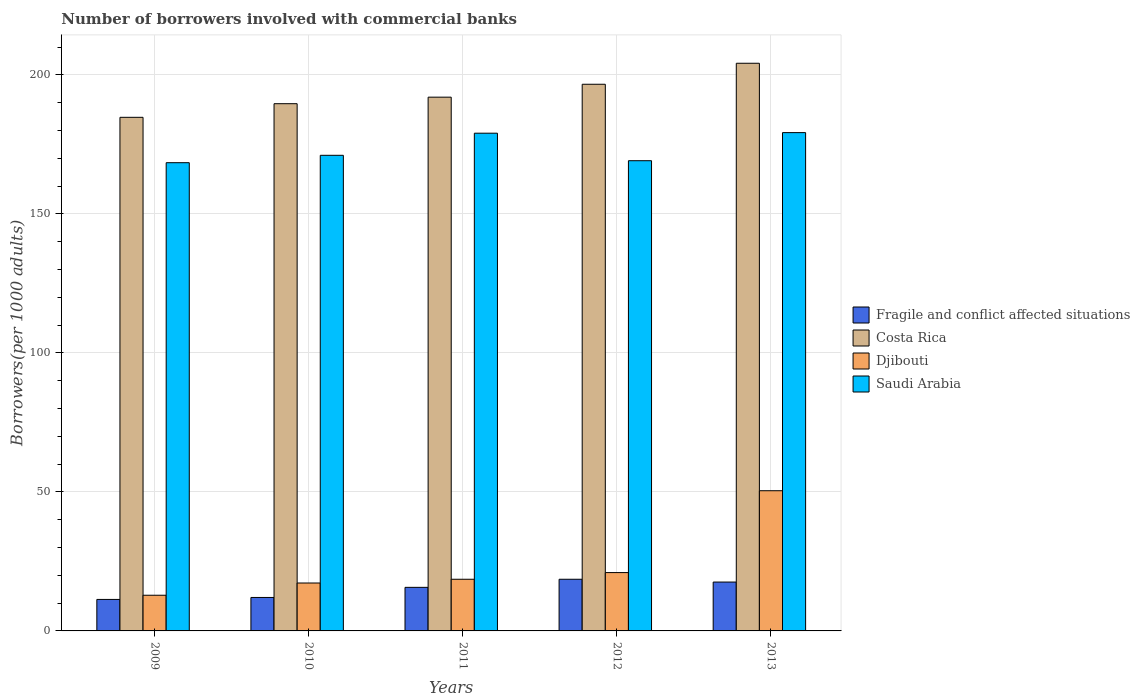How many different coloured bars are there?
Your answer should be very brief. 4. Are the number of bars on each tick of the X-axis equal?
Keep it short and to the point. Yes. How many bars are there on the 4th tick from the left?
Make the answer very short. 4. What is the number of borrowers involved with commercial banks in Djibouti in 2009?
Offer a very short reply. 12.83. Across all years, what is the maximum number of borrowers involved with commercial banks in Fragile and conflict affected situations?
Your response must be concise. 18.58. Across all years, what is the minimum number of borrowers involved with commercial banks in Costa Rica?
Keep it short and to the point. 184.73. In which year was the number of borrowers involved with commercial banks in Saudi Arabia maximum?
Provide a short and direct response. 2013. What is the total number of borrowers involved with commercial banks in Fragile and conflict affected situations in the graph?
Make the answer very short. 75.19. What is the difference between the number of borrowers involved with commercial banks in Fragile and conflict affected situations in 2010 and that in 2012?
Ensure brevity in your answer.  -6.55. What is the difference between the number of borrowers involved with commercial banks in Saudi Arabia in 2011 and the number of borrowers involved with commercial banks in Djibouti in 2012?
Your answer should be very brief. 158.04. What is the average number of borrowers involved with commercial banks in Djibouti per year?
Offer a terse response. 24.01. In the year 2009, what is the difference between the number of borrowers involved with commercial banks in Fragile and conflict affected situations and number of borrowers involved with commercial banks in Djibouti?
Provide a short and direct response. -1.5. In how many years, is the number of borrowers involved with commercial banks in Djibouti greater than 120?
Ensure brevity in your answer.  0. What is the ratio of the number of borrowers involved with commercial banks in Djibouti in 2009 to that in 2013?
Provide a short and direct response. 0.25. Is the difference between the number of borrowers involved with commercial banks in Fragile and conflict affected situations in 2012 and 2013 greater than the difference between the number of borrowers involved with commercial banks in Djibouti in 2012 and 2013?
Offer a terse response. Yes. What is the difference between the highest and the second highest number of borrowers involved with commercial banks in Fragile and conflict affected situations?
Make the answer very short. 1. What is the difference between the highest and the lowest number of borrowers involved with commercial banks in Costa Rica?
Offer a very short reply. 19.45. In how many years, is the number of borrowers involved with commercial banks in Costa Rica greater than the average number of borrowers involved with commercial banks in Costa Rica taken over all years?
Give a very brief answer. 2. What does the 4th bar from the left in 2011 represents?
Make the answer very short. Saudi Arabia. What does the 4th bar from the right in 2012 represents?
Make the answer very short. Fragile and conflict affected situations. Is it the case that in every year, the sum of the number of borrowers involved with commercial banks in Fragile and conflict affected situations and number of borrowers involved with commercial banks in Costa Rica is greater than the number of borrowers involved with commercial banks in Djibouti?
Your response must be concise. Yes. How many bars are there?
Ensure brevity in your answer.  20. Are all the bars in the graph horizontal?
Ensure brevity in your answer.  No. How many years are there in the graph?
Ensure brevity in your answer.  5. What is the difference between two consecutive major ticks on the Y-axis?
Give a very brief answer. 50. Does the graph contain any zero values?
Offer a very short reply. No. Does the graph contain grids?
Your response must be concise. Yes. Where does the legend appear in the graph?
Your response must be concise. Center right. How are the legend labels stacked?
Provide a succinct answer. Vertical. What is the title of the graph?
Your response must be concise. Number of borrowers involved with commercial banks. What is the label or title of the Y-axis?
Keep it short and to the point. Borrowers(per 1000 adults). What is the Borrowers(per 1000 adults) in Fragile and conflict affected situations in 2009?
Make the answer very short. 11.33. What is the Borrowers(per 1000 adults) in Costa Rica in 2009?
Your answer should be compact. 184.73. What is the Borrowers(per 1000 adults) in Djibouti in 2009?
Give a very brief answer. 12.83. What is the Borrowers(per 1000 adults) of Saudi Arabia in 2009?
Keep it short and to the point. 168.41. What is the Borrowers(per 1000 adults) in Fragile and conflict affected situations in 2010?
Keep it short and to the point. 12.03. What is the Borrowers(per 1000 adults) of Costa Rica in 2010?
Your answer should be compact. 189.63. What is the Borrowers(per 1000 adults) in Djibouti in 2010?
Make the answer very short. 17.23. What is the Borrowers(per 1000 adults) in Saudi Arabia in 2010?
Give a very brief answer. 171.07. What is the Borrowers(per 1000 adults) in Fragile and conflict affected situations in 2011?
Provide a succinct answer. 15.67. What is the Borrowers(per 1000 adults) in Costa Rica in 2011?
Your answer should be compact. 191.98. What is the Borrowers(per 1000 adults) of Djibouti in 2011?
Make the answer very short. 18.58. What is the Borrowers(per 1000 adults) in Saudi Arabia in 2011?
Offer a very short reply. 179.02. What is the Borrowers(per 1000 adults) of Fragile and conflict affected situations in 2012?
Keep it short and to the point. 18.58. What is the Borrowers(per 1000 adults) in Costa Rica in 2012?
Your answer should be compact. 196.62. What is the Borrowers(per 1000 adults) in Djibouti in 2012?
Your answer should be compact. 20.98. What is the Borrowers(per 1000 adults) in Saudi Arabia in 2012?
Your answer should be compact. 169.13. What is the Borrowers(per 1000 adults) in Fragile and conflict affected situations in 2013?
Your answer should be compact. 17.58. What is the Borrowers(per 1000 adults) in Costa Rica in 2013?
Ensure brevity in your answer.  204.18. What is the Borrowers(per 1000 adults) of Djibouti in 2013?
Make the answer very short. 50.43. What is the Borrowers(per 1000 adults) in Saudi Arabia in 2013?
Give a very brief answer. 179.23. Across all years, what is the maximum Borrowers(per 1000 adults) in Fragile and conflict affected situations?
Provide a succinct answer. 18.58. Across all years, what is the maximum Borrowers(per 1000 adults) in Costa Rica?
Your answer should be very brief. 204.18. Across all years, what is the maximum Borrowers(per 1000 adults) of Djibouti?
Make the answer very short. 50.43. Across all years, what is the maximum Borrowers(per 1000 adults) of Saudi Arabia?
Your answer should be very brief. 179.23. Across all years, what is the minimum Borrowers(per 1000 adults) in Fragile and conflict affected situations?
Provide a succinct answer. 11.33. Across all years, what is the minimum Borrowers(per 1000 adults) of Costa Rica?
Give a very brief answer. 184.73. Across all years, what is the minimum Borrowers(per 1000 adults) of Djibouti?
Offer a terse response. 12.83. Across all years, what is the minimum Borrowers(per 1000 adults) in Saudi Arabia?
Offer a very short reply. 168.41. What is the total Borrowers(per 1000 adults) of Fragile and conflict affected situations in the graph?
Offer a very short reply. 75.19. What is the total Borrowers(per 1000 adults) of Costa Rica in the graph?
Offer a terse response. 967.14. What is the total Borrowers(per 1000 adults) of Djibouti in the graph?
Provide a succinct answer. 120.05. What is the total Borrowers(per 1000 adults) in Saudi Arabia in the graph?
Keep it short and to the point. 866.85. What is the difference between the Borrowers(per 1000 adults) in Fragile and conflict affected situations in 2009 and that in 2010?
Ensure brevity in your answer.  -0.7. What is the difference between the Borrowers(per 1000 adults) in Costa Rica in 2009 and that in 2010?
Give a very brief answer. -4.9. What is the difference between the Borrowers(per 1000 adults) in Djibouti in 2009 and that in 2010?
Provide a succinct answer. -4.4. What is the difference between the Borrowers(per 1000 adults) in Saudi Arabia in 2009 and that in 2010?
Your response must be concise. -2.65. What is the difference between the Borrowers(per 1000 adults) in Fragile and conflict affected situations in 2009 and that in 2011?
Offer a very short reply. -4.34. What is the difference between the Borrowers(per 1000 adults) in Costa Rica in 2009 and that in 2011?
Provide a short and direct response. -7.25. What is the difference between the Borrowers(per 1000 adults) of Djibouti in 2009 and that in 2011?
Your answer should be very brief. -5.75. What is the difference between the Borrowers(per 1000 adults) in Saudi Arabia in 2009 and that in 2011?
Make the answer very short. -10.61. What is the difference between the Borrowers(per 1000 adults) in Fragile and conflict affected situations in 2009 and that in 2012?
Ensure brevity in your answer.  -7.25. What is the difference between the Borrowers(per 1000 adults) in Costa Rica in 2009 and that in 2012?
Your answer should be very brief. -11.9. What is the difference between the Borrowers(per 1000 adults) in Djibouti in 2009 and that in 2012?
Provide a short and direct response. -8.15. What is the difference between the Borrowers(per 1000 adults) in Saudi Arabia in 2009 and that in 2012?
Ensure brevity in your answer.  -0.71. What is the difference between the Borrowers(per 1000 adults) of Fragile and conflict affected situations in 2009 and that in 2013?
Offer a terse response. -6.25. What is the difference between the Borrowers(per 1000 adults) of Costa Rica in 2009 and that in 2013?
Give a very brief answer. -19.45. What is the difference between the Borrowers(per 1000 adults) in Djibouti in 2009 and that in 2013?
Keep it short and to the point. -37.59. What is the difference between the Borrowers(per 1000 adults) in Saudi Arabia in 2009 and that in 2013?
Offer a very short reply. -10.82. What is the difference between the Borrowers(per 1000 adults) of Fragile and conflict affected situations in 2010 and that in 2011?
Give a very brief answer. -3.64. What is the difference between the Borrowers(per 1000 adults) of Costa Rica in 2010 and that in 2011?
Ensure brevity in your answer.  -2.35. What is the difference between the Borrowers(per 1000 adults) of Djibouti in 2010 and that in 2011?
Keep it short and to the point. -1.35. What is the difference between the Borrowers(per 1000 adults) in Saudi Arabia in 2010 and that in 2011?
Your answer should be very brief. -7.96. What is the difference between the Borrowers(per 1000 adults) of Fragile and conflict affected situations in 2010 and that in 2012?
Ensure brevity in your answer.  -6.55. What is the difference between the Borrowers(per 1000 adults) of Costa Rica in 2010 and that in 2012?
Provide a succinct answer. -6.99. What is the difference between the Borrowers(per 1000 adults) of Djibouti in 2010 and that in 2012?
Ensure brevity in your answer.  -3.75. What is the difference between the Borrowers(per 1000 adults) in Saudi Arabia in 2010 and that in 2012?
Make the answer very short. 1.94. What is the difference between the Borrowers(per 1000 adults) in Fragile and conflict affected situations in 2010 and that in 2013?
Provide a short and direct response. -5.55. What is the difference between the Borrowers(per 1000 adults) in Costa Rica in 2010 and that in 2013?
Ensure brevity in your answer.  -14.55. What is the difference between the Borrowers(per 1000 adults) in Djibouti in 2010 and that in 2013?
Your answer should be very brief. -33.19. What is the difference between the Borrowers(per 1000 adults) in Saudi Arabia in 2010 and that in 2013?
Provide a succinct answer. -8.16. What is the difference between the Borrowers(per 1000 adults) of Fragile and conflict affected situations in 2011 and that in 2012?
Your response must be concise. -2.91. What is the difference between the Borrowers(per 1000 adults) in Costa Rica in 2011 and that in 2012?
Keep it short and to the point. -4.64. What is the difference between the Borrowers(per 1000 adults) of Djibouti in 2011 and that in 2012?
Make the answer very short. -2.4. What is the difference between the Borrowers(per 1000 adults) in Saudi Arabia in 2011 and that in 2012?
Ensure brevity in your answer.  9.9. What is the difference between the Borrowers(per 1000 adults) of Fragile and conflict affected situations in 2011 and that in 2013?
Keep it short and to the point. -1.91. What is the difference between the Borrowers(per 1000 adults) in Costa Rica in 2011 and that in 2013?
Your answer should be very brief. -12.19. What is the difference between the Borrowers(per 1000 adults) in Djibouti in 2011 and that in 2013?
Give a very brief answer. -31.85. What is the difference between the Borrowers(per 1000 adults) of Saudi Arabia in 2011 and that in 2013?
Offer a very short reply. -0.21. What is the difference between the Borrowers(per 1000 adults) of Costa Rica in 2012 and that in 2013?
Keep it short and to the point. -7.55. What is the difference between the Borrowers(per 1000 adults) of Djibouti in 2012 and that in 2013?
Your response must be concise. -29.45. What is the difference between the Borrowers(per 1000 adults) of Saudi Arabia in 2012 and that in 2013?
Your answer should be very brief. -10.1. What is the difference between the Borrowers(per 1000 adults) of Fragile and conflict affected situations in 2009 and the Borrowers(per 1000 adults) of Costa Rica in 2010?
Give a very brief answer. -178.3. What is the difference between the Borrowers(per 1000 adults) in Fragile and conflict affected situations in 2009 and the Borrowers(per 1000 adults) in Djibouti in 2010?
Your answer should be compact. -5.91. What is the difference between the Borrowers(per 1000 adults) in Fragile and conflict affected situations in 2009 and the Borrowers(per 1000 adults) in Saudi Arabia in 2010?
Provide a succinct answer. -159.74. What is the difference between the Borrowers(per 1000 adults) in Costa Rica in 2009 and the Borrowers(per 1000 adults) in Djibouti in 2010?
Provide a succinct answer. 167.49. What is the difference between the Borrowers(per 1000 adults) in Costa Rica in 2009 and the Borrowers(per 1000 adults) in Saudi Arabia in 2010?
Your response must be concise. 13.66. What is the difference between the Borrowers(per 1000 adults) in Djibouti in 2009 and the Borrowers(per 1000 adults) in Saudi Arabia in 2010?
Your answer should be compact. -158.23. What is the difference between the Borrowers(per 1000 adults) of Fragile and conflict affected situations in 2009 and the Borrowers(per 1000 adults) of Costa Rica in 2011?
Offer a terse response. -180.65. What is the difference between the Borrowers(per 1000 adults) of Fragile and conflict affected situations in 2009 and the Borrowers(per 1000 adults) of Djibouti in 2011?
Offer a very short reply. -7.25. What is the difference between the Borrowers(per 1000 adults) of Fragile and conflict affected situations in 2009 and the Borrowers(per 1000 adults) of Saudi Arabia in 2011?
Ensure brevity in your answer.  -167.69. What is the difference between the Borrowers(per 1000 adults) of Costa Rica in 2009 and the Borrowers(per 1000 adults) of Djibouti in 2011?
Offer a terse response. 166.15. What is the difference between the Borrowers(per 1000 adults) of Costa Rica in 2009 and the Borrowers(per 1000 adults) of Saudi Arabia in 2011?
Your answer should be very brief. 5.71. What is the difference between the Borrowers(per 1000 adults) of Djibouti in 2009 and the Borrowers(per 1000 adults) of Saudi Arabia in 2011?
Provide a short and direct response. -166.19. What is the difference between the Borrowers(per 1000 adults) in Fragile and conflict affected situations in 2009 and the Borrowers(per 1000 adults) in Costa Rica in 2012?
Your answer should be very brief. -185.29. What is the difference between the Borrowers(per 1000 adults) in Fragile and conflict affected situations in 2009 and the Borrowers(per 1000 adults) in Djibouti in 2012?
Keep it short and to the point. -9.65. What is the difference between the Borrowers(per 1000 adults) of Fragile and conflict affected situations in 2009 and the Borrowers(per 1000 adults) of Saudi Arabia in 2012?
Give a very brief answer. -157.8. What is the difference between the Borrowers(per 1000 adults) in Costa Rica in 2009 and the Borrowers(per 1000 adults) in Djibouti in 2012?
Ensure brevity in your answer.  163.75. What is the difference between the Borrowers(per 1000 adults) of Costa Rica in 2009 and the Borrowers(per 1000 adults) of Saudi Arabia in 2012?
Provide a succinct answer. 15.6. What is the difference between the Borrowers(per 1000 adults) in Djibouti in 2009 and the Borrowers(per 1000 adults) in Saudi Arabia in 2012?
Your answer should be compact. -156.29. What is the difference between the Borrowers(per 1000 adults) of Fragile and conflict affected situations in 2009 and the Borrowers(per 1000 adults) of Costa Rica in 2013?
Keep it short and to the point. -192.85. What is the difference between the Borrowers(per 1000 adults) of Fragile and conflict affected situations in 2009 and the Borrowers(per 1000 adults) of Djibouti in 2013?
Make the answer very short. -39.1. What is the difference between the Borrowers(per 1000 adults) in Fragile and conflict affected situations in 2009 and the Borrowers(per 1000 adults) in Saudi Arabia in 2013?
Offer a terse response. -167.9. What is the difference between the Borrowers(per 1000 adults) in Costa Rica in 2009 and the Borrowers(per 1000 adults) in Djibouti in 2013?
Ensure brevity in your answer.  134.3. What is the difference between the Borrowers(per 1000 adults) of Costa Rica in 2009 and the Borrowers(per 1000 adults) of Saudi Arabia in 2013?
Make the answer very short. 5.5. What is the difference between the Borrowers(per 1000 adults) of Djibouti in 2009 and the Borrowers(per 1000 adults) of Saudi Arabia in 2013?
Provide a succinct answer. -166.4. What is the difference between the Borrowers(per 1000 adults) of Fragile and conflict affected situations in 2010 and the Borrowers(per 1000 adults) of Costa Rica in 2011?
Keep it short and to the point. -179.95. What is the difference between the Borrowers(per 1000 adults) of Fragile and conflict affected situations in 2010 and the Borrowers(per 1000 adults) of Djibouti in 2011?
Your answer should be very brief. -6.55. What is the difference between the Borrowers(per 1000 adults) of Fragile and conflict affected situations in 2010 and the Borrowers(per 1000 adults) of Saudi Arabia in 2011?
Your answer should be compact. -166.99. What is the difference between the Borrowers(per 1000 adults) in Costa Rica in 2010 and the Borrowers(per 1000 adults) in Djibouti in 2011?
Your response must be concise. 171.05. What is the difference between the Borrowers(per 1000 adults) of Costa Rica in 2010 and the Borrowers(per 1000 adults) of Saudi Arabia in 2011?
Offer a terse response. 10.61. What is the difference between the Borrowers(per 1000 adults) in Djibouti in 2010 and the Borrowers(per 1000 adults) in Saudi Arabia in 2011?
Ensure brevity in your answer.  -161.79. What is the difference between the Borrowers(per 1000 adults) in Fragile and conflict affected situations in 2010 and the Borrowers(per 1000 adults) in Costa Rica in 2012?
Provide a short and direct response. -184.59. What is the difference between the Borrowers(per 1000 adults) in Fragile and conflict affected situations in 2010 and the Borrowers(per 1000 adults) in Djibouti in 2012?
Ensure brevity in your answer.  -8.95. What is the difference between the Borrowers(per 1000 adults) of Fragile and conflict affected situations in 2010 and the Borrowers(per 1000 adults) of Saudi Arabia in 2012?
Offer a terse response. -157.09. What is the difference between the Borrowers(per 1000 adults) in Costa Rica in 2010 and the Borrowers(per 1000 adults) in Djibouti in 2012?
Provide a succinct answer. 168.65. What is the difference between the Borrowers(per 1000 adults) in Costa Rica in 2010 and the Borrowers(per 1000 adults) in Saudi Arabia in 2012?
Offer a very short reply. 20.5. What is the difference between the Borrowers(per 1000 adults) of Djibouti in 2010 and the Borrowers(per 1000 adults) of Saudi Arabia in 2012?
Keep it short and to the point. -151.89. What is the difference between the Borrowers(per 1000 adults) of Fragile and conflict affected situations in 2010 and the Borrowers(per 1000 adults) of Costa Rica in 2013?
Give a very brief answer. -192.14. What is the difference between the Borrowers(per 1000 adults) in Fragile and conflict affected situations in 2010 and the Borrowers(per 1000 adults) in Djibouti in 2013?
Provide a short and direct response. -38.39. What is the difference between the Borrowers(per 1000 adults) in Fragile and conflict affected situations in 2010 and the Borrowers(per 1000 adults) in Saudi Arabia in 2013?
Your answer should be compact. -167.2. What is the difference between the Borrowers(per 1000 adults) in Costa Rica in 2010 and the Borrowers(per 1000 adults) in Djibouti in 2013?
Provide a short and direct response. 139.2. What is the difference between the Borrowers(per 1000 adults) in Costa Rica in 2010 and the Borrowers(per 1000 adults) in Saudi Arabia in 2013?
Give a very brief answer. 10.4. What is the difference between the Borrowers(per 1000 adults) in Djibouti in 2010 and the Borrowers(per 1000 adults) in Saudi Arabia in 2013?
Give a very brief answer. -161.99. What is the difference between the Borrowers(per 1000 adults) of Fragile and conflict affected situations in 2011 and the Borrowers(per 1000 adults) of Costa Rica in 2012?
Ensure brevity in your answer.  -180.95. What is the difference between the Borrowers(per 1000 adults) of Fragile and conflict affected situations in 2011 and the Borrowers(per 1000 adults) of Djibouti in 2012?
Make the answer very short. -5.31. What is the difference between the Borrowers(per 1000 adults) of Fragile and conflict affected situations in 2011 and the Borrowers(per 1000 adults) of Saudi Arabia in 2012?
Keep it short and to the point. -153.46. What is the difference between the Borrowers(per 1000 adults) in Costa Rica in 2011 and the Borrowers(per 1000 adults) in Djibouti in 2012?
Your answer should be compact. 171. What is the difference between the Borrowers(per 1000 adults) in Costa Rica in 2011 and the Borrowers(per 1000 adults) in Saudi Arabia in 2012?
Provide a short and direct response. 22.86. What is the difference between the Borrowers(per 1000 adults) of Djibouti in 2011 and the Borrowers(per 1000 adults) of Saudi Arabia in 2012?
Your answer should be very brief. -150.55. What is the difference between the Borrowers(per 1000 adults) of Fragile and conflict affected situations in 2011 and the Borrowers(per 1000 adults) of Costa Rica in 2013?
Make the answer very short. -188.51. What is the difference between the Borrowers(per 1000 adults) of Fragile and conflict affected situations in 2011 and the Borrowers(per 1000 adults) of Djibouti in 2013?
Offer a terse response. -34.76. What is the difference between the Borrowers(per 1000 adults) in Fragile and conflict affected situations in 2011 and the Borrowers(per 1000 adults) in Saudi Arabia in 2013?
Provide a short and direct response. -163.56. What is the difference between the Borrowers(per 1000 adults) of Costa Rica in 2011 and the Borrowers(per 1000 adults) of Djibouti in 2013?
Provide a short and direct response. 141.56. What is the difference between the Borrowers(per 1000 adults) in Costa Rica in 2011 and the Borrowers(per 1000 adults) in Saudi Arabia in 2013?
Your answer should be very brief. 12.75. What is the difference between the Borrowers(per 1000 adults) of Djibouti in 2011 and the Borrowers(per 1000 adults) of Saudi Arabia in 2013?
Provide a short and direct response. -160.65. What is the difference between the Borrowers(per 1000 adults) in Fragile and conflict affected situations in 2012 and the Borrowers(per 1000 adults) in Costa Rica in 2013?
Your answer should be very brief. -185.59. What is the difference between the Borrowers(per 1000 adults) in Fragile and conflict affected situations in 2012 and the Borrowers(per 1000 adults) in Djibouti in 2013?
Provide a succinct answer. -31.84. What is the difference between the Borrowers(per 1000 adults) in Fragile and conflict affected situations in 2012 and the Borrowers(per 1000 adults) in Saudi Arabia in 2013?
Your answer should be compact. -160.65. What is the difference between the Borrowers(per 1000 adults) in Costa Rica in 2012 and the Borrowers(per 1000 adults) in Djibouti in 2013?
Ensure brevity in your answer.  146.2. What is the difference between the Borrowers(per 1000 adults) in Costa Rica in 2012 and the Borrowers(per 1000 adults) in Saudi Arabia in 2013?
Your response must be concise. 17.39. What is the difference between the Borrowers(per 1000 adults) of Djibouti in 2012 and the Borrowers(per 1000 adults) of Saudi Arabia in 2013?
Your answer should be compact. -158.25. What is the average Borrowers(per 1000 adults) of Fragile and conflict affected situations per year?
Ensure brevity in your answer.  15.04. What is the average Borrowers(per 1000 adults) of Costa Rica per year?
Your answer should be very brief. 193.43. What is the average Borrowers(per 1000 adults) in Djibouti per year?
Provide a short and direct response. 24.01. What is the average Borrowers(per 1000 adults) in Saudi Arabia per year?
Your answer should be compact. 173.37. In the year 2009, what is the difference between the Borrowers(per 1000 adults) in Fragile and conflict affected situations and Borrowers(per 1000 adults) in Costa Rica?
Provide a short and direct response. -173.4. In the year 2009, what is the difference between the Borrowers(per 1000 adults) in Fragile and conflict affected situations and Borrowers(per 1000 adults) in Djibouti?
Offer a very short reply. -1.5. In the year 2009, what is the difference between the Borrowers(per 1000 adults) of Fragile and conflict affected situations and Borrowers(per 1000 adults) of Saudi Arabia?
Give a very brief answer. -157.08. In the year 2009, what is the difference between the Borrowers(per 1000 adults) in Costa Rica and Borrowers(per 1000 adults) in Djibouti?
Give a very brief answer. 171.9. In the year 2009, what is the difference between the Borrowers(per 1000 adults) in Costa Rica and Borrowers(per 1000 adults) in Saudi Arabia?
Keep it short and to the point. 16.32. In the year 2009, what is the difference between the Borrowers(per 1000 adults) of Djibouti and Borrowers(per 1000 adults) of Saudi Arabia?
Make the answer very short. -155.58. In the year 2010, what is the difference between the Borrowers(per 1000 adults) in Fragile and conflict affected situations and Borrowers(per 1000 adults) in Costa Rica?
Offer a very short reply. -177.6. In the year 2010, what is the difference between the Borrowers(per 1000 adults) of Fragile and conflict affected situations and Borrowers(per 1000 adults) of Djibouti?
Provide a short and direct response. -5.2. In the year 2010, what is the difference between the Borrowers(per 1000 adults) in Fragile and conflict affected situations and Borrowers(per 1000 adults) in Saudi Arabia?
Your answer should be very brief. -159.03. In the year 2010, what is the difference between the Borrowers(per 1000 adults) in Costa Rica and Borrowers(per 1000 adults) in Djibouti?
Your answer should be compact. 172.39. In the year 2010, what is the difference between the Borrowers(per 1000 adults) in Costa Rica and Borrowers(per 1000 adults) in Saudi Arabia?
Provide a short and direct response. 18.56. In the year 2010, what is the difference between the Borrowers(per 1000 adults) in Djibouti and Borrowers(per 1000 adults) in Saudi Arabia?
Offer a very short reply. -153.83. In the year 2011, what is the difference between the Borrowers(per 1000 adults) of Fragile and conflict affected situations and Borrowers(per 1000 adults) of Costa Rica?
Your answer should be compact. -176.31. In the year 2011, what is the difference between the Borrowers(per 1000 adults) in Fragile and conflict affected situations and Borrowers(per 1000 adults) in Djibouti?
Your response must be concise. -2.91. In the year 2011, what is the difference between the Borrowers(per 1000 adults) in Fragile and conflict affected situations and Borrowers(per 1000 adults) in Saudi Arabia?
Ensure brevity in your answer.  -163.35. In the year 2011, what is the difference between the Borrowers(per 1000 adults) of Costa Rica and Borrowers(per 1000 adults) of Djibouti?
Provide a short and direct response. 173.4. In the year 2011, what is the difference between the Borrowers(per 1000 adults) in Costa Rica and Borrowers(per 1000 adults) in Saudi Arabia?
Give a very brief answer. 12.96. In the year 2011, what is the difference between the Borrowers(per 1000 adults) of Djibouti and Borrowers(per 1000 adults) of Saudi Arabia?
Ensure brevity in your answer.  -160.44. In the year 2012, what is the difference between the Borrowers(per 1000 adults) in Fragile and conflict affected situations and Borrowers(per 1000 adults) in Costa Rica?
Your answer should be compact. -178.04. In the year 2012, what is the difference between the Borrowers(per 1000 adults) of Fragile and conflict affected situations and Borrowers(per 1000 adults) of Djibouti?
Offer a terse response. -2.4. In the year 2012, what is the difference between the Borrowers(per 1000 adults) in Fragile and conflict affected situations and Borrowers(per 1000 adults) in Saudi Arabia?
Make the answer very short. -150.54. In the year 2012, what is the difference between the Borrowers(per 1000 adults) of Costa Rica and Borrowers(per 1000 adults) of Djibouti?
Your answer should be very brief. 175.64. In the year 2012, what is the difference between the Borrowers(per 1000 adults) in Costa Rica and Borrowers(per 1000 adults) in Saudi Arabia?
Offer a terse response. 27.5. In the year 2012, what is the difference between the Borrowers(per 1000 adults) in Djibouti and Borrowers(per 1000 adults) in Saudi Arabia?
Give a very brief answer. -148.15. In the year 2013, what is the difference between the Borrowers(per 1000 adults) in Fragile and conflict affected situations and Borrowers(per 1000 adults) in Costa Rica?
Keep it short and to the point. -186.6. In the year 2013, what is the difference between the Borrowers(per 1000 adults) of Fragile and conflict affected situations and Borrowers(per 1000 adults) of Djibouti?
Make the answer very short. -32.85. In the year 2013, what is the difference between the Borrowers(per 1000 adults) of Fragile and conflict affected situations and Borrowers(per 1000 adults) of Saudi Arabia?
Provide a succinct answer. -161.65. In the year 2013, what is the difference between the Borrowers(per 1000 adults) in Costa Rica and Borrowers(per 1000 adults) in Djibouti?
Offer a terse response. 153.75. In the year 2013, what is the difference between the Borrowers(per 1000 adults) of Costa Rica and Borrowers(per 1000 adults) of Saudi Arabia?
Give a very brief answer. 24.95. In the year 2013, what is the difference between the Borrowers(per 1000 adults) in Djibouti and Borrowers(per 1000 adults) in Saudi Arabia?
Your answer should be very brief. -128.8. What is the ratio of the Borrowers(per 1000 adults) in Fragile and conflict affected situations in 2009 to that in 2010?
Provide a succinct answer. 0.94. What is the ratio of the Borrowers(per 1000 adults) in Costa Rica in 2009 to that in 2010?
Your answer should be compact. 0.97. What is the ratio of the Borrowers(per 1000 adults) in Djibouti in 2009 to that in 2010?
Give a very brief answer. 0.74. What is the ratio of the Borrowers(per 1000 adults) of Saudi Arabia in 2009 to that in 2010?
Your answer should be very brief. 0.98. What is the ratio of the Borrowers(per 1000 adults) of Fragile and conflict affected situations in 2009 to that in 2011?
Keep it short and to the point. 0.72. What is the ratio of the Borrowers(per 1000 adults) in Costa Rica in 2009 to that in 2011?
Your answer should be very brief. 0.96. What is the ratio of the Borrowers(per 1000 adults) of Djibouti in 2009 to that in 2011?
Provide a short and direct response. 0.69. What is the ratio of the Borrowers(per 1000 adults) of Saudi Arabia in 2009 to that in 2011?
Keep it short and to the point. 0.94. What is the ratio of the Borrowers(per 1000 adults) in Fragile and conflict affected situations in 2009 to that in 2012?
Your response must be concise. 0.61. What is the ratio of the Borrowers(per 1000 adults) of Costa Rica in 2009 to that in 2012?
Keep it short and to the point. 0.94. What is the ratio of the Borrowers(per 1000 adults) of Djibouti in 2009 to that in 2012?
Your answer should be compact. 0.61. What is the ratio of the Borrowers(per 1000 adults) in Saudi Arabia in 2009 to that in 2012?
Give a very brief answer. 1. What is the ratio of the Borrowers(per 1000 adults) of Fragile and conflict affected situations in 2009 to that in 2013?
Ensure brevity in your answer.  0.64. What is the ratio of the Borrowers(per 1000 adults) of Costa Rica in 2009 to that in 2013?
Give a very brief answer. 0.9. What is the ratio of the Borrowers(per 1000 adults) in Djibouti in 2009 to that in 2013?
Offer a very short reply. 0.25. What is the ratio of the Borrowers(per 1000 adults) in Saudi Arabia in 2009 to that in 2013?
Your answer should be compact. 0.94. What is the ratio of the Borrowers(per 1000 adults) in Fragile and conflict affected situations in 2010 to that in 2011?
Provide a short and direct response. 0.77. What is the ratio of the Borrowers(per 1000 adults) in Costa Rica in 2010 to that in 2011?
Offer a terse response. 0.99. What is the ratio of the Borrowers(per 1000 adults) in Djibouti in 2010 to that in 2011?
Offer a terse response. 0.93. What is the ratio of the Borrowers(per 1000 adults) in Saudi Arabia in 2010 to that in 2011?
Your answer should be compact. 0.96. What is the ratio of the Borrowers(per 1000 adults) of Fragile and conflict affected situations in 2010 to that in 2012?
Your answer should be compact. 0.65. What is the ratio of the Borrowers(per 1000 adults) in Costa Rica in 2010 to that in 2012?
Your answer should be compact. 0.96. What is the ratio of the Borrowers(per 1000 adults) of Djibouti in 2010 to that in 2012?
Offer a very short reply. 0.82. What is the ratio of the Borrowers(per 1000 adults) in Saudi Arabia in 2010 to that in 2012?
Your response must be concise. 1.01. What is the ratio of the Borrowers(per 1000 adults) of Fragile and conflict affected situations in 2010 to that in 2013?
Offer a terse response. 0.68. What is the ratio of the Borrowers(per 1000 adults) of Costa Rica in 2010 to that in 2013?
Offer a very short reply. 0.93. What is the ratio of the Borrowers(per 1000 adults) in Djibouti in 2010 to that in 2013?
Your answer should be very brief. 0.34. What is the ratio of the Borrowers(per 1000 adults) in Saudi Arabia in 2010 to that in 2013?
Provide a short and direct response. 0.95. What is the ratio of the Borrowers(per 1000 adults) in Fragile and conflict affected situations in 2011 to that in 2012?
Ensure brevity in your answer.  0.84. What is the ratio of the Borrowers(per 1000 adults) in Costa Rica in 2011 to that in 2012?
Keep it short and to the point. 0.98. What is the ratio of the Borrowers(per 1000 adults) in Djibouti in 2011 to that in 2012?
Offer a very short reply. 0.89. What is the ratio of the Borrowers(per 1000 adults) of Saudi Arabia in 2011 to that in 2012?
Keep it short and to the point. 1.06. What is the ratio of the Borrowers(per 1000 adults) in Fragile and conflict affected situations in 2011 to that in 2013?
Give a very brief answer. 0.89. What is the ratio of the Borrowers(per 1000 adults) of Costa Rica in 2011 to that in 2013?
Your answer should be compact. 0.94. What is the ratio of the Borrowers(per 1000 adults) of Djibouti in 2011 to that in 2013?
Make the answer very short. 0.37. What is the ratio of the Borrowers(per 1000 adults) of Saudi Arabia in 2011 to that in 2013?
Your response must be concise. 1. What is the ratio of the Borrowers(per 1000 adults) in Fragile and conflict affected situations in 2012 to that in 2013?
Your response must be concise. 1.06. What is the ratio of the Borrowers(per 1000 adults) in Djibouti in 2012 to that in 2013?
Your answer should be very brief. 0.42. What is the ratio of the Borrowers(per 1000 adults) of Saudi Arabia in 2012 to that in 2013?
Offer a terse response. 0.94. What is the difference between the highest and the second highest Borrowers(per 1000 adults) in Fragile and conflict affected situations?
Your response must be concise. 1. What is the difference between the highest and the second highest Borrowers(per 1000 adults) of Costa Rica?
Ensure brevity in your answer.  7.55. What is the difference between the highest and the second highest Borrowers(per 1000 adults) in Djibouti?
Give a very brief answer. 29.45. What is the difference between the highest and the second highest Borrowers(per 1000 adults) in Saudi Arabia?
Ensure brevity in your answer.  0.21. What is the difference between the highest and the lowest Borrowers(per 1000 adults) of Fragile and conflict affected situations?
Give a very brief answer. 7.25. What is the difference between the highest and the lowest Borrowers(per 1000 adults) in Costa Rica?
Keep it short and to the point. 19.45. What is the difference between the highest and the lowest Borrowers(per 1000 adults) of Djibouti?
Ensure brevity in your answer.  37.59. What is the difference between the highest and the lowest Borrowers(per 1000 adults) in Saudi Arabia?
Provide a short and direct response. 10.82. 